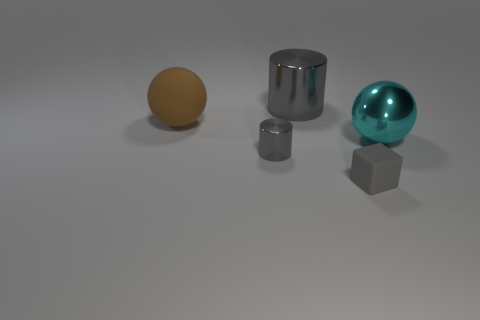Add 2 gray cylinders. How many objects exist? 7 Subtract all cylinders. How many objects are left? 3 Subtract 0 red balls. How many objects are left? 5 Subtract all tiny gray blocks. Subtract all big brown rubber objects. How many objects are left? 3 Add 3 big cyan metal things. How many big cyan metal things are left? 4 Add 3 cylinders. How many cylinders exist? 5 